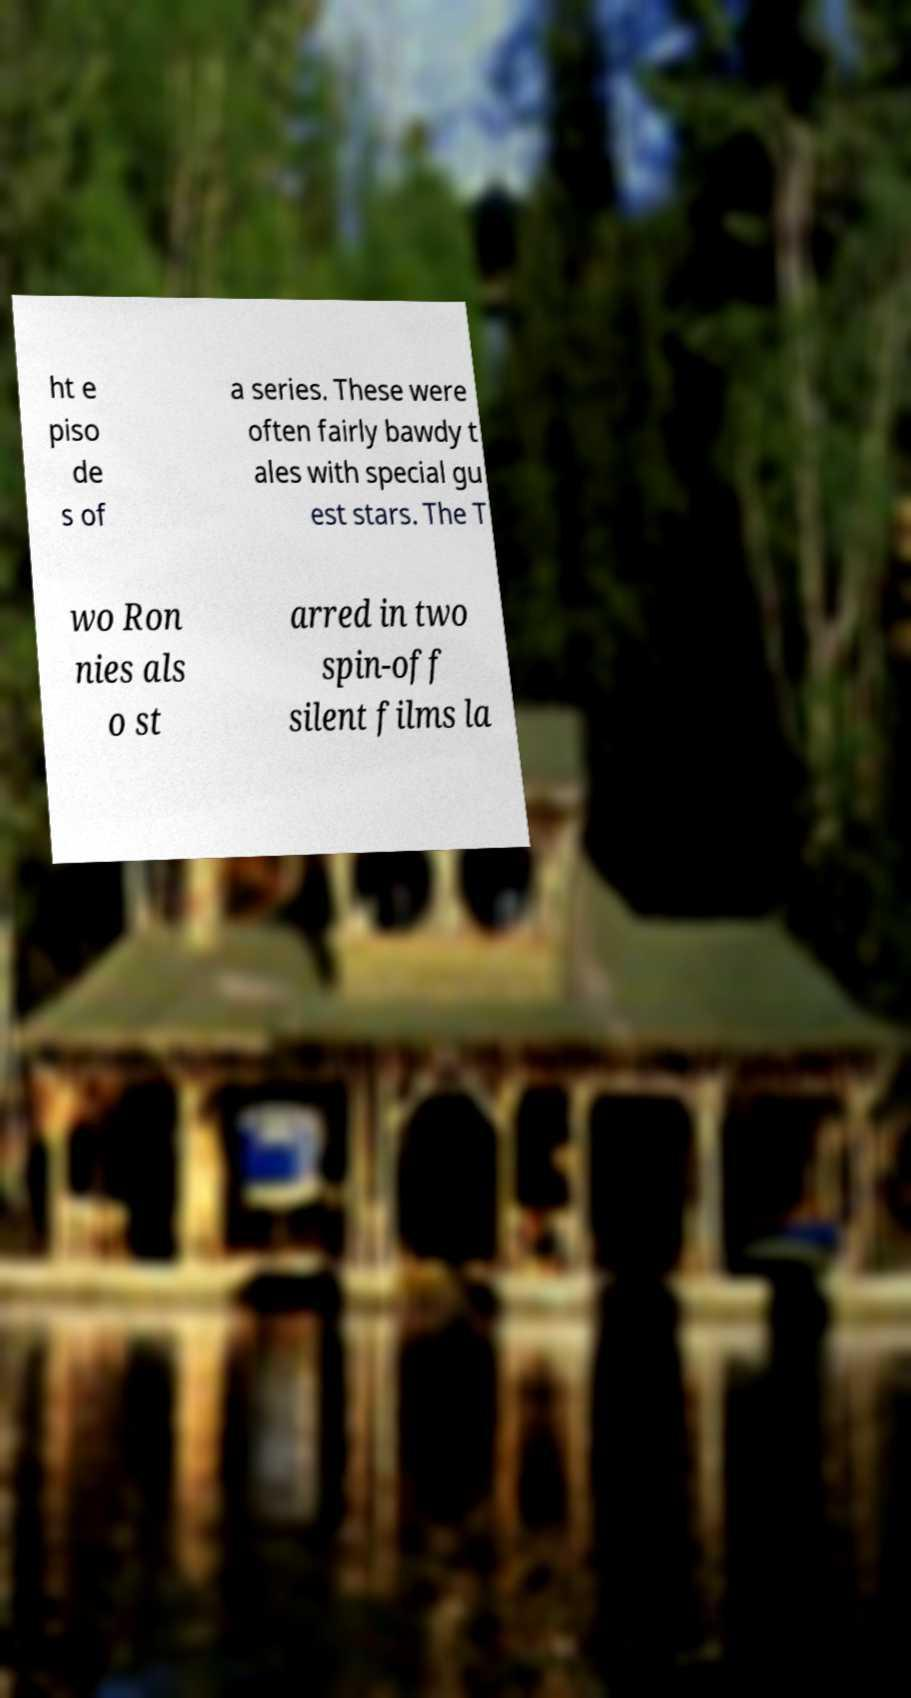Please identify and transcribe the text found in this image. ht e piso de s of a series. These were often fairly bawdy t ales with special gu est stars. The T wo Ron nies als o st arred in two spin-off silent films la 